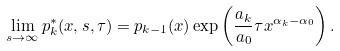<formula> <loc_0><loc_0><loc_500><loc_500>\lim _ { s \rightarrow \infty } p _ { k } ^ { * } ( x , s , \tau ) = p _ { k - 1 } ( x ) \exp \left ( \frac { a _ { k } } { a _ { 0 } } \tau x ^ { \alpha _ { k } - \alpha _ { 0 } } \right ) .</formula> 